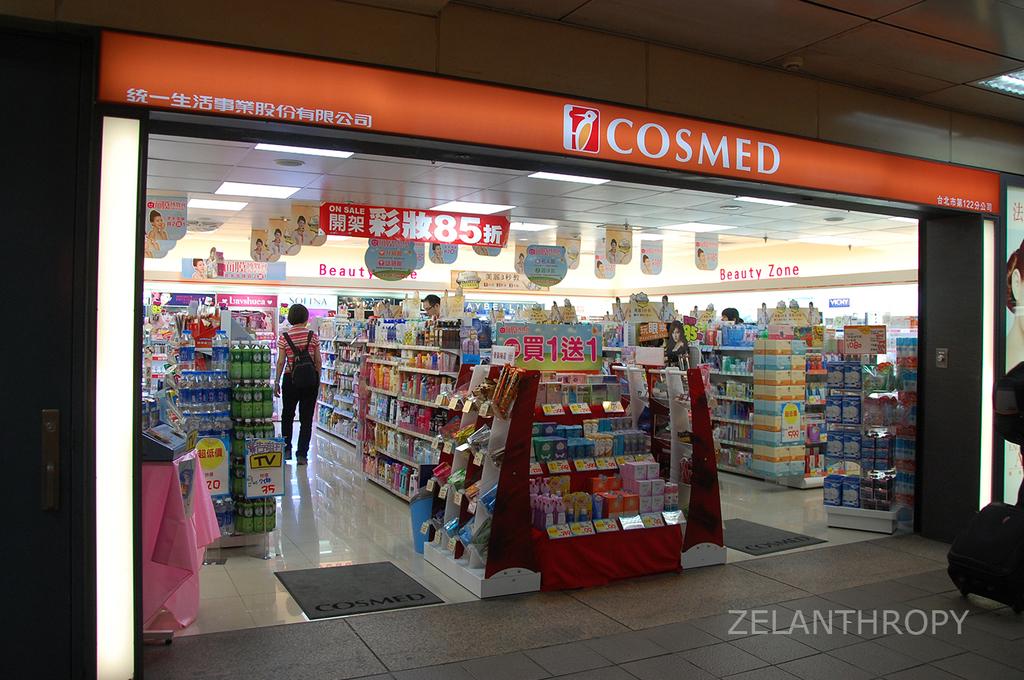What is the name of the store?
Make the answer very short. Cosmed. 